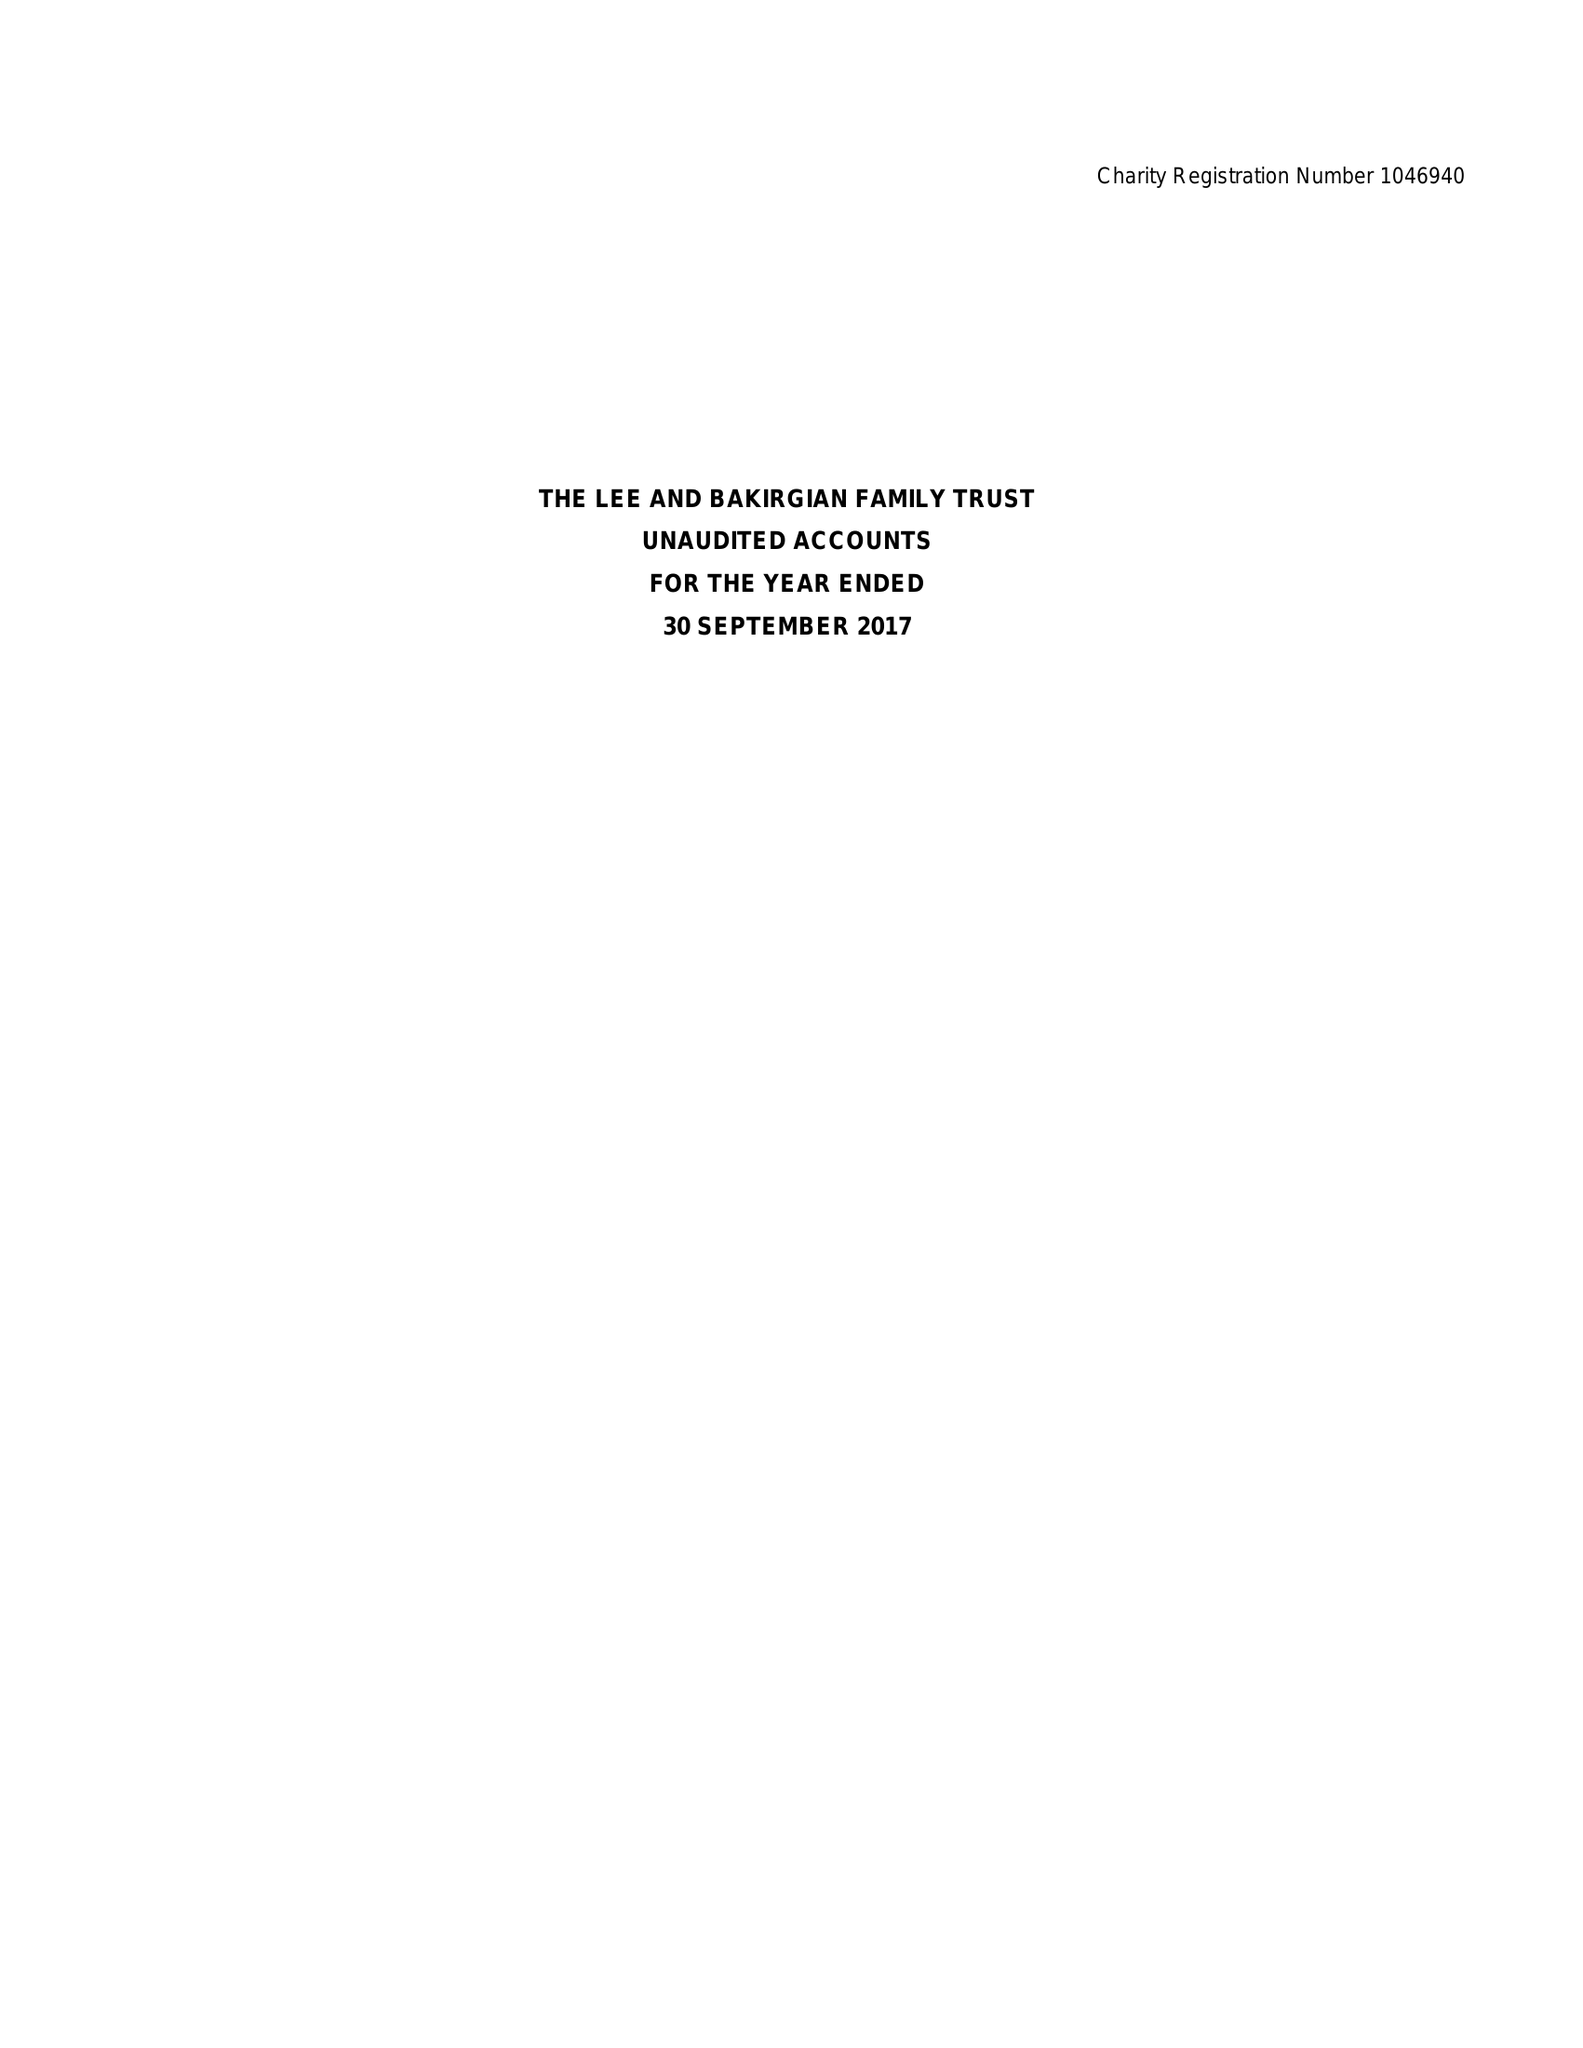What is the value for the income_annually_in_british_pounds?
Answer the question using a single word or phrase. 27597.00 